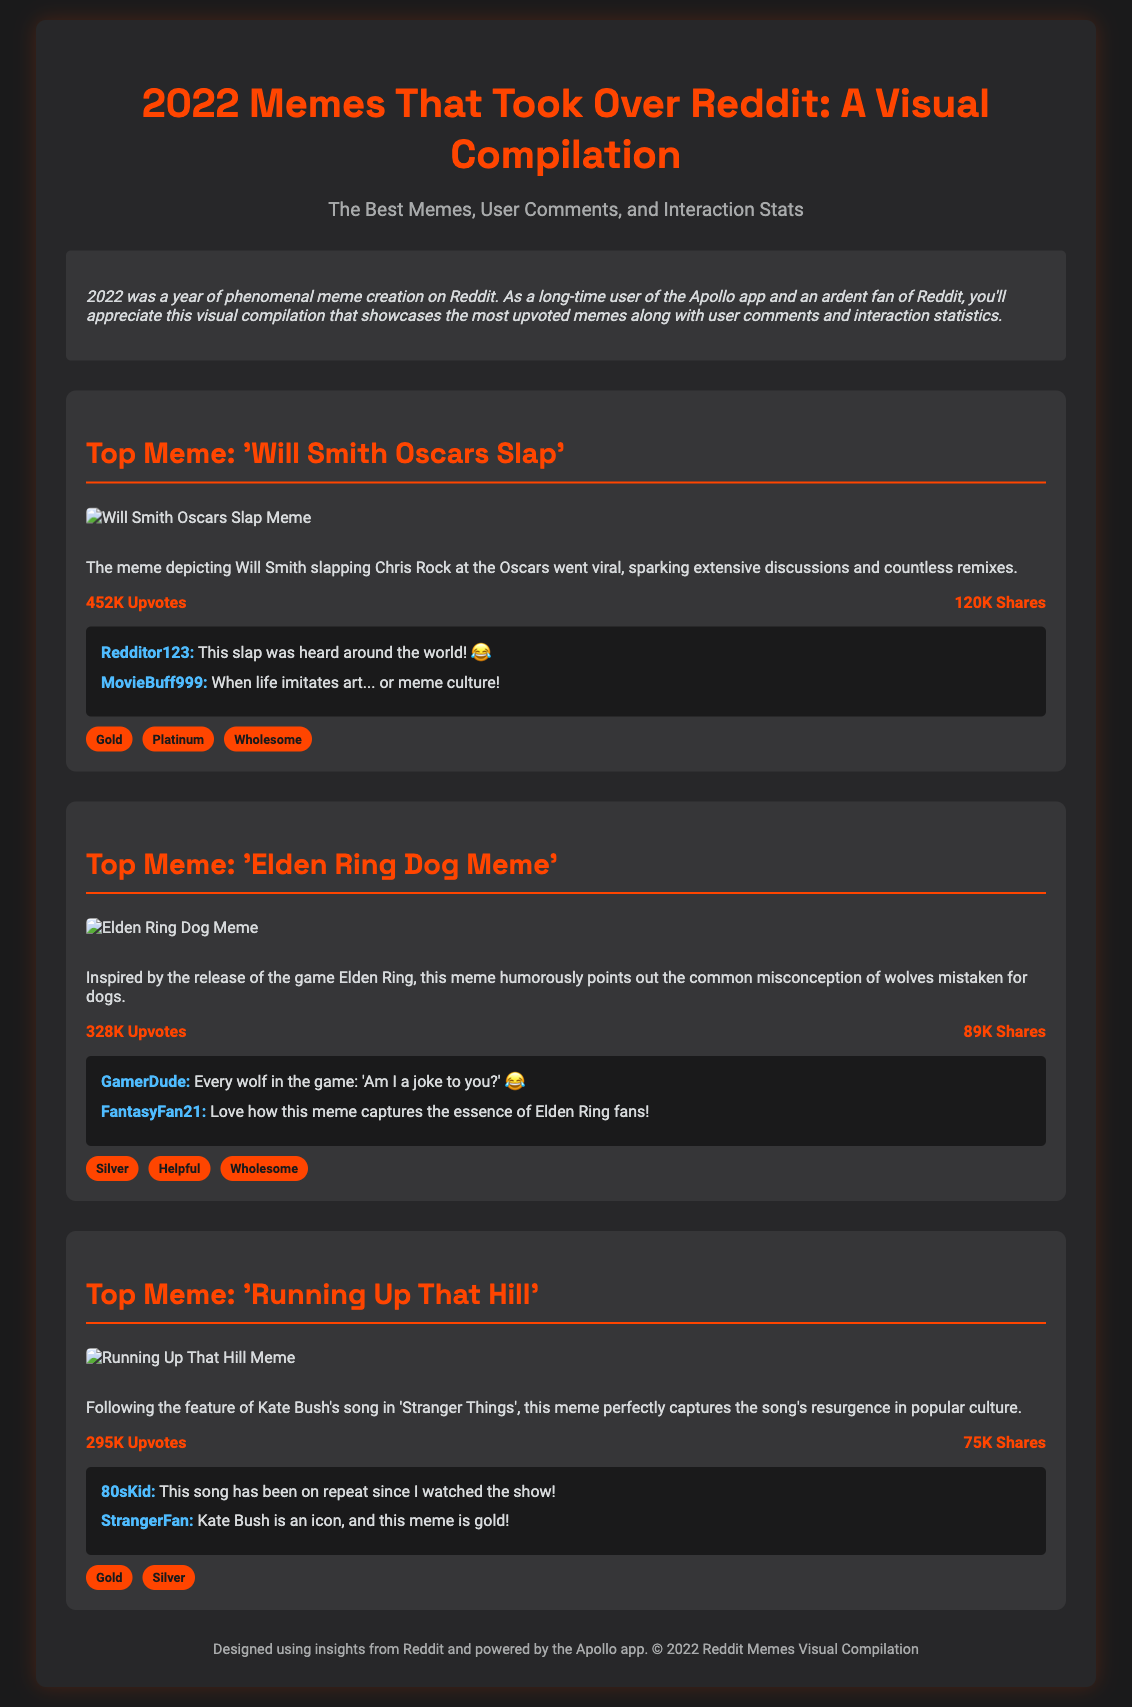what is the title of the document? The title of the document is explicitly stated at the top and introduces the content.
Answer: 2022 Memes That Took Over Reddit: A Visual Compilation how many upvotes did the 'Will Smith Oscars Slap' meme receive? The number of upvotes is given in the stats section of that specific meme.
Answer: 452K Upvotes what was the main theme of the 'Elden Ring Dog Meme'? The theme is described in the text accompanying the meme, summarizing its humor and inspiration.
Answer: Misconception of wolves mistaken for dogs which meme received the most shares? The number of shares for each meme is noted and can be compared to deduce which is highest.
Answer: 'Will Smith Oscars Slap' who commented "This song has been on repeat since I watched the show!"? The user who made a specific comment on the meme is provided in the comments section.
Answer: 80sKid how many comments are listed under the 'Running Up That Hill' meme? The total number of comments is discernible from the document by counting the instances.
Answer: 2 comments what awards did the 'Running Up That Hill' meme receive? The awards are listed at the bottom of the meme's section, presenting recognitions received.
Answer: Gold, Silver which meme was featured in 'Stranger Things'? The introduction or description of the meme provides context about its referencing in a popular show.
Answer: 'Running Up That Hill' 